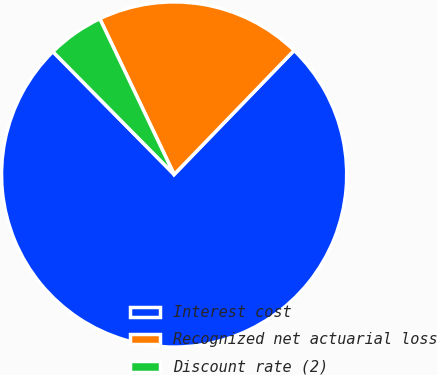<chart> <loc_0><loc_0><loc_500><loc_500><pie_chart><fcel>Interest cost<fcel>Recognized net actuarial loss<fcel>Discount rate (2)<nl><fcel>75.36%<fcel>19.32%<fcel>5.31%<nl></chart> 